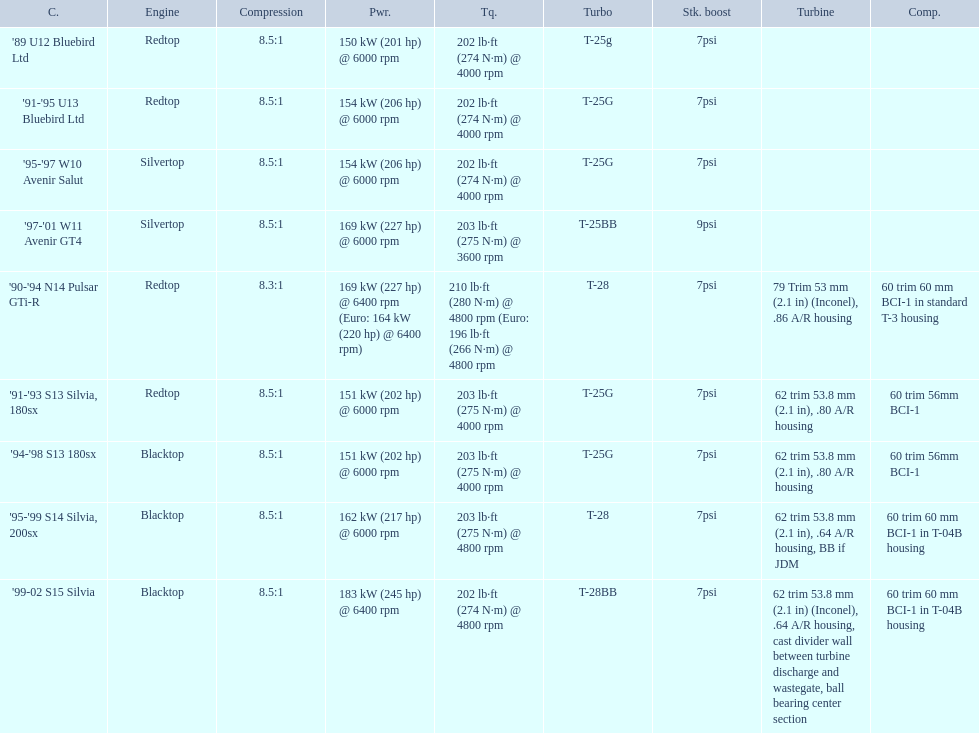Which of the cars uses the redtop engine? '89 U12 Bluebird Ltd, '91-'95 U13 Bluebird Ltd, '90-'94 N14 Pulsar GTi-R, '91-'93 S13 Silvia, 180sx. Of these, has more than 220 horsepower? '90-'94 N14 Pulsar GTi-R. What is the compression ratio of this car? 8.3:1. 